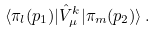Convert formula to latex. <formula><loc_0><loc_0><loc_500><loc_500>\langle \pi _ { l } ( p _ { 1 } ) | \hat { V } _ { \mu } ^ { k } | \pi _ { m } ( p _ { 2 } ) \rangle \, .</formula> 